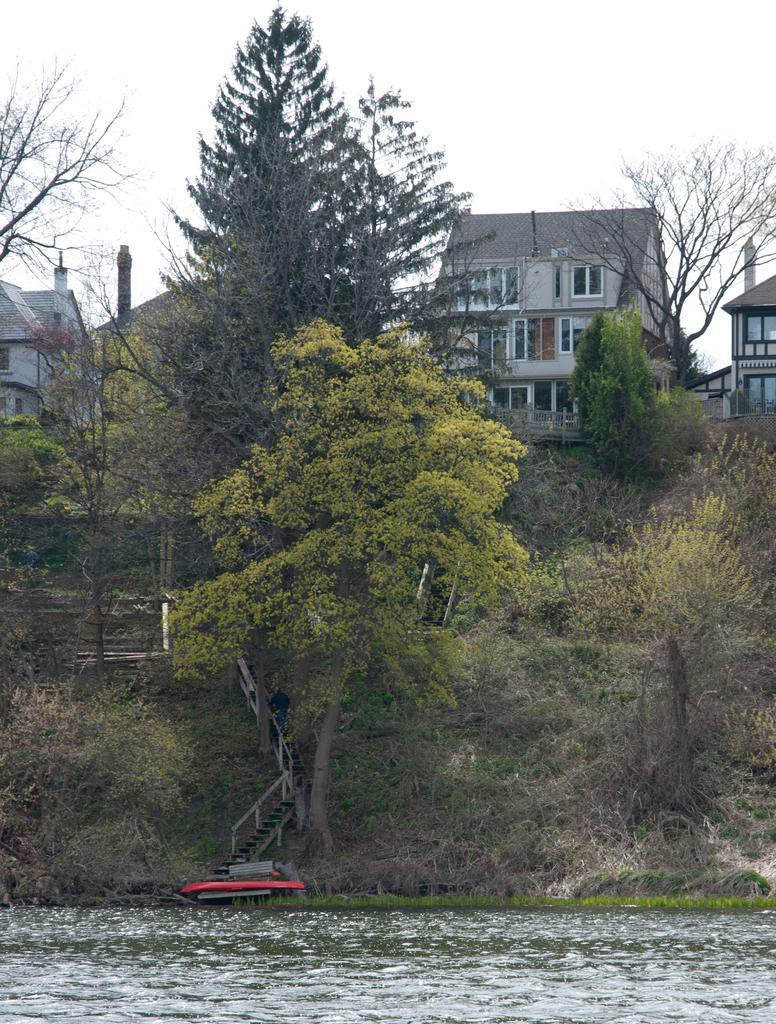Can you describe this image briefly? In front of the image there is water. At the bottom of the image there is grass on the surface. There is a person standing on the stairs. In front of the stairs there are some objects. In the background of the image there are trees, buildings and sky. 